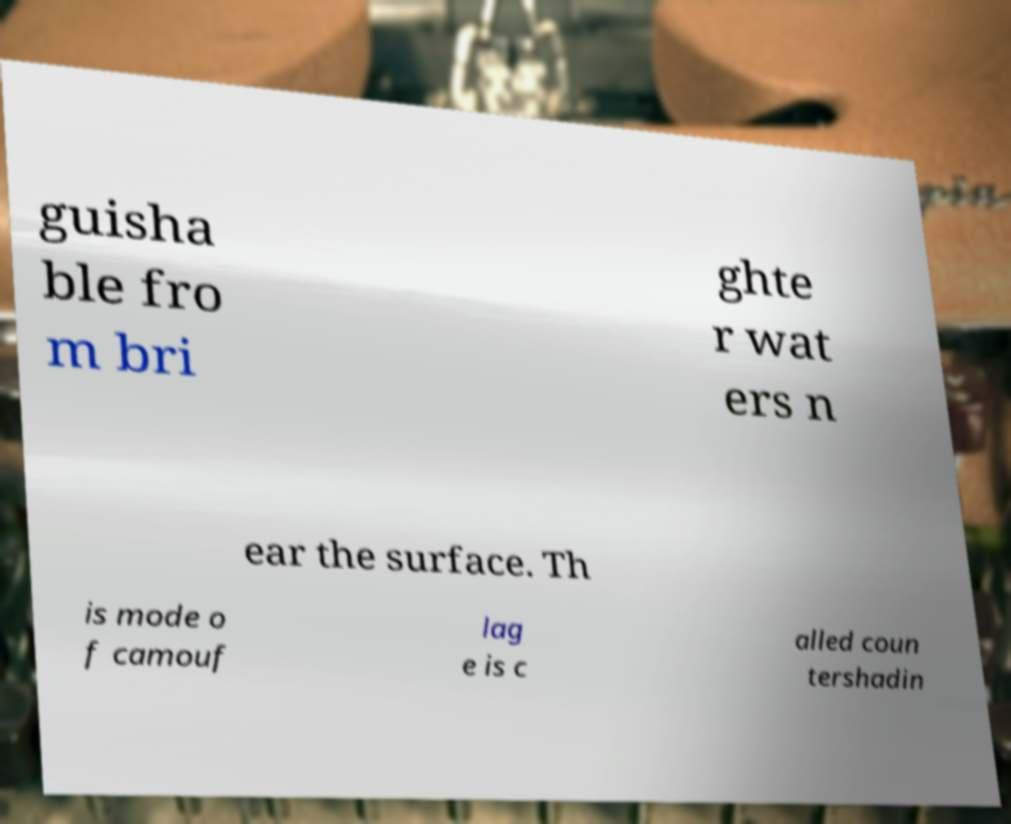There's text embedded in this image that I need extracted. Can you transcribe it verbatim? guisha ble fro m bri ghte r wat ers n ear the surface. Th is mode o f camouf lag e is c alled coun tershadin 